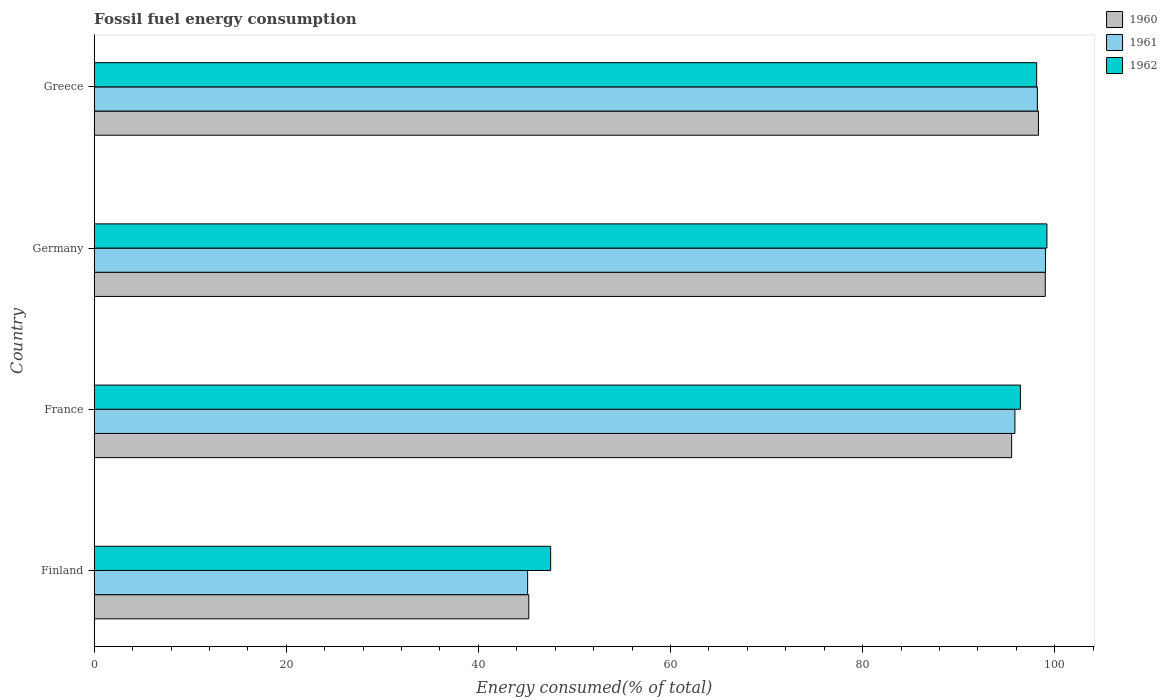How many different coloured bars are there?
Give a very brief answer. 3. How many bars are there on the 3rd tick from the top?
Offer a terse response. 3. What is the label of the 3rd group of bars from the top?
Offer a very short reply. France. What is the percentage of energy consumed in 1960 in Germany?
Your answer should be very brief. 99.02. Across all countries, what is the maximum percentage of energy consumed in 1962?
Keep it short and to the point. 99.19. Across all countries, what is the minimum percentage of energy consumed in 1962?
Ensure brevity in your answer.  47.52. In which country was the percentage of energy consumed in 1962 maximum?
Provide a short and direct response. Germany. In which country was the percentage of energy consumed in 1960 minimum?
Give a very brief answer. Finland. What is the total percentage of energy consumed in 1961 in the graph?
Keep it short and to the point. 338.23. What is the difference between the percentage of energy consumed in 1961 in Finland and that in France?
Provide a succinct answer. -50.73. What is the difference between the percentage of energy consumed in 1961 in Greece and the percentage of energy consumed in 1962 in Germany?
Your answer should be very brief. -0.99. What is the average percentage of energy consumed in 1962 per country?
Provide a succinct answer. 85.32. What is the difference between the percentage of energy consumed in 1961 and percentage of energy consumed in 1960 in Germany?
Provide a short and direct response. 0.02. What is the ratio of the percentage of energy consumed in 1961 in Germany to that in Greece?
Ensure brevity in your answer.  1.01. Is the percentage of energy consumed in 1961 in Finland less than that in Greece?
Make the answer very short. Yes. Is the difference between the percentage of energy consumed in 1961 in Germany and Greece greater than the difference between the percentage of energy consumed in 1960 in Germany and Greece?
Keep it short and to the point. Yes. What is the difference between the highest and the second highest percentage of energy consumed in 1961?
Give a very brief answer. 0.84. What is the difference between the highest and the lowest percentage of energy consumed in 1961?
Offer a very short reply. 53.91. In how many countries, is the percentage of energy consumed in 1962 greater than the average percentage of energy consumed in 1962 taken over all countries?
Your answer should be very brief. 3. Is the sum of the percentage of energy consumed in 1960 in Finland and Greece greater than the maximum percentage of energy consumed in 1962 across all countries?
Provide a succinct answer. Yes. Is it the case that in every country, the sum of the percentage of energy consumed in 1962 and percentage of energy consumed in 1960 is greater than the percentage of energy consumed in 1961?
Ensure brevity in your answer.  Yes. How many bars are there?
Make the answer very short. 12. Are all the bars in the graph horizontal?
Keep it short and to the point. Yes. What is the difference between two consecutive major ticks on the X-axis?
Offer a very short reply. 20. Does the graph contain any zero values?
Your answer should be compact. No. Does the graph contain grids?
Provide a short and direct response. No. How many legend labels are there?
Your answer should be compact. 3. How are the legend labels stacked?
Ensure brevity in your answer.  Vertical. What is the title of the graph?
Your answer should be compact. Fossil fuel energy consumption. Does "2010" appear as one of the legend labels in the graph?
Provide a succinct answer. No. What is the label or title of the X-axis?
Ensure brevity in your answer.  Energy consumed(% of total). What is the label or title of the Y-axis?
Offer a terse response. Country. What is the Energy consumed(% of total) in 1960 in Finland?
Make the answer very short. 45.25. What is the Energy consumed(% of total) of 1961 in Finland?
Keep it short and to the point. 45.13. What is the Energy consumed(% of total) of 1962 in Finland?
Keep it short and to the point. 47.52. What is the Energy consumed(% of total) in 1960 in France?
Offer a very short reply. 95.52. What is the Energy consumed(% of total) in 1961 in France?
Your answer should be very brief. 95.86. What is the Energy consumed(% of total) in 1962 in France?
Your answer should be compact. 96.43. What is the Energy consumed(% of total) in 1960 in Germany?
Your answer should be very brief. 99.02. What is the Energy consumed(% of total) of 1961 in Germany?
Offer a terse response. 99.04. What is the Energy consumed(% of total) in 1962 in Germany?
Offer a very short reply. 99.19. What is the Energy consumed(% of total) in 1960 in Greece?
Keep it short and to the point. 98.31. What is the Energy consumed(% of total) in 1961 in Greece?
Make the answer very short. 98.2. What is the Energy consumed(% of total) of 1962 in Greece?
Offer a very short reply. 98.12. Across all countries, what is the maximum Energy consumed(% of total) of 1960?
Provide a succinct answer. 99.02. Across all countries, what is the maximum Energy consumed(% of total) of 1961?
Provide a succinct answer. 99.04. Across all countries, what is the maximum Energy consumed(% of total) in 1962?
Provide a short and direct response. 99.19. Across all countries, what is the minimum Energy consumed(% of total) in 1960?
Your answer should be compact. 45.25. Across all countries, what is the minimum Energy consumed(% of total) in 1961?
Your answer should be very brief. 45.13. Across all countries, what is the minimum Energy consumed(% of total) in 1962?
Give a very brief answer. 47.52. What is the total Energy consumed(% of total) in 1960 in the graph?
Offer a very short reply. 338.1. What is the total Energy consumed(% of total) in 1961 in the graph?
Offer a terse response. 338.23. What is the total Energy consumed(% of total) in 1962 in the graph?
Provide a succinct answer. 341.27. What is the difference between the Energy consumed(% of total) in 1960 in Finland and that in France?
Give a very brief answer. -50.27. What is the difference between the Energy consumed(% of total) in 1961 in Finland and that in France?
Your answer should be very brief. -50.73. What is the difference between the Energy consumed(% of total) of 1962 in Finland and that in France?
Your response must be concise. -48.91. What is the difference between the Energy consumed(% of total) of 1960 in Finland and that in Germany?
Ensure brevity in your answer.  -53.77. What is the difference between the Energy consumed(% of total) of 1961 in Finland and that in Germany?
Provide a short and direct response. -53.91. What is the difference between the Energy consumed(% of total) of 1962 in Finland and that in Germany?
Your answer should be very brief. -51.67. What is the difference between the Energy consumed(% of total) in 1960 in Finland and that in Greece?
Your answer should be very brief. -53.07. What is the difference between the Energy consumed(% of total) of 1961 in Finland and that in Greece?
Your response must be concise. -53.07. What is the difference between the Energy consumed(% of total) in 1962 in Finland and that in Greece?
Provide a short and direct response. -50.6. What is the difference between the Energy consumed(% of total) of 1961 in France and that in Germany?
Ensure brevity in your answer.  -3.18. What is the difference between the Energy consumed(% of total) in 1962 in France and that in Germany?
Your answer should be very brief. -2.76. What is the difference between the Energy consumed(% of total) in 1960 in France and that in Greece?
Give a very brief answer. -2.79. What is the difference between the Energy consumed(% of total) in 1961 in France and that in Greece?
Keep it short and to the point. -2.34. What is the difference between the Energy consumed(% of total) in 1962 in France and that in Greece?
Your response must be concise. -1.69. What is the difference between the Energy consumed(% of total) of 1960 in Germany and that in Greece?
Make the answer very short. 0.71. What is the difference between the Energy consumed(% of total) of 1961 in Germany and that in Greece?
Ensure brevity in your answer.  0.84. What is the difference between the Energy consumed(% of total) in 1962 in Germany and that in Greece?
Provide a succinct answer. 1.07. What is the difference between the Energy consumed(% of total) in 1960 in Finland and the Energy consumed(% of total) in 1961 in France?
Your response must be concise. -50.62. What is the difference between the Energy consumed(% of total) in 1960 in Finland and the Energy consumed(% of total) in 1962 in France?
Ensure brevity in your answer.  -51.19. What is the difference between the Energy consumed(% of total) of 1961 in Finland and the Energy consumed(% of total) of 1962 in France?
Provide a short and direct response. -51.3. What is the difference between the Energy consumed(% of total) of 1960 in Finland and the Energy consumed(% of total) of 1961 in Germany?
Your answer should be compact. -53.8. What is the difference between the Energy consumed(% of total) of 1960 in Finland and the Energy consumed(% of total) of 1962 in Germany?
Provide a short and direct response. -53.95. What is the difference between the Energy consumed(% of total) of 1961 in Finland and the Energy consumed(% of total) of 1962 in Germany?
Your answer should be very brief. -54.06. What is the difference between the Energy consumed(% of total) in 1960 in Finland and the Energy consumed(% of total) in 1961 in Greece?
Give a very brief answer. -52.95. What is the difference between the Energy consumed(% of total) in 1960 in Finland and the Energy consumed(% of total) in 1962 in Greece?
Your answer should be very brief. -52.88. What is the difference between the Energy consumed(% of total) in 1961 in Finland and the Energy consumed(% of total) in 1962 in Greece?
Offer a very short reply. -53. What is the difference between the Energy consumed(% of total) of 1960 in France and the Energy consumed(% of total) of 1961 in Germany?
Provide a short and direct response. -3.52. What is the difference between the Energy consumed(% of total) of 1960 in France and the Energy consumed(% of total) of 1962 in Germany?
Keep it short and to the point. -3.67. What is the difference between the Energy consumed(% of total) of 1961 in France and the Energy consumed(% of total) of 1962 in Germany?
Offer a terse response. -3.33. What is the difference between the Energy consumed(% of total) in 1960 in France and the Energy consumed(% of total) in 1961 in Greece?
Make the answer very short. -2.68. What is the difference between the Energy consumed(% of total) of 1960 in France and the Energy consumed(% of total) of 1962 in Greece?
Provide a short and direct response. -2.6. What is the difference between the Energy consumed(% of total) in 1961 in France and the Energy consumed(% of total) in 1962 in Greece?
Keep it short and to the point. -2.26. What is the difference between the Energy consumed(% of total) of 1960 in Germany and the Energy consumed(% of total) of 1961 in Greece?
Give a very brief answer. 0.82. What is the difference between the Energy consumed(% of total) of 1960 in Germany and the Energy consumed(% of total) of 1962 in Greece?
Give a very brief answer. 0.9. What is the difference between the Energy consumed(% of total) in 1961 in Germany and the Energy consumed(% of total) in 1962 in Greece?
Make the answer very short. 0.92. What is the average Energy consumed(% of total) in 1960 per country?
Your response must be concise. 84.52. What is the average Energy consumed(% of total) in 1961 per country?
Offer a very short reply. 84.56. What is the average Energy consumed(% of total) in 1962 per country?
Provide a succinct answer. 85.32. What is the difference between the Energy consumed(% of total) of 1960 and Energy consumed(% of total) of 1961 in Finland?
Ensure brevity in your answer.  0.12. What is the difference between the Energy consumed(% of total) in 1960 and Energy consumed(% of total) in 1962 in Finland?
Give a very brief answer. -2.28. What is the difference between the Energy consumed(% of total) of 1961 and Energy consumed(% of total) of 1962 in Finland?
Keep it short and to the point. -2.4. What is the difference between the Energy consumed(% of total) of 1960 and Energy consumed(% of total) of 1961 in France?
Provide a short and direct response. -0.34. What is the difference between the Energy consumed(% of total) in 1960 and Energy consumed(% of total) in 1962 in France?
Ensure brevity in your answer.  -0.91. What is the difference between the Energy consumed(% of total) in 1961 and Energy consumed(% of total) in 1962 in France?
Give a very brief answer. -0.57. What is the difference between the Energy consumed(% of total) in 1960 and Energy consumed(% of total) in 1961 in Germany?
Keep it short and to the point. -0.02. What is the difference between the Energy consumed(% of total) in 1960 and Energy consumed(% of total) in 1962 in Germany?
Your response must be concise. -0.17. What is the difference between the Energy consumed(% of total) in 1961 and Energy consumed(% of total) in 1962 in Germany?
Make the answer very short. -0.15. What is the difference between the Energy consumed(% of total) of 1960 and Energy consumed(% of total) of 1961 in Greece?
Provide a short and direct response. 0.11. What is the difference between the Energy consumed(% of total) of 1960 and Energy consumed(% of total) of 1962 in Greece?
Ensure brevity in your answer.  0.19. What is the difference between the Energy consumed(% of total) of 1961 and Energy consumed(% of total) of 1962 in Greece?
Ensure brevity in your answer.  0.07. What is the ratio of the Energy consumed(% of total) in 1960 in Finland to that in France?
Provide a short and direct response. 0.47. What is the ratio of the Energy consumed(% of total) of 1961 in Finland to that in France?
Offer a very short reply. 0.47. What is the ratio of the Energy consumed(% of total) in 1962 in Finland to that in France?
Your response must be concise. 0.49. What is the ratio of the Energy consumed(% of total) in 1960 in Finland to that in Germany?
Provide a short and direct response. 0.46. What is the ratio of the Energy consumed(% of total) in 1961 in Finland to that in Germany?
Your answer should be compact. 0.46. What is the ratio of the Energy consumed(% of total) in 1962 in Finland to that in Germany?
Your answer should be very brief. 0.48. What is the ratio of the Energy consumed(% of total) of 1960 in Finland to that in Greece?
Make the answer very short. 0.46. What is the ratio of the Energy consumed(% of total) in 1961 in Finland to that in Greece?
Keep it short and to the point. 0.46. What is the ratio of the Energy consumed(% of total) in 1962 in Finland to that in Greece?
Ensure brevity in your answer.  0.48. What is the ratio of the Energy consumed(% of total) in 1960 in France to that in Germany?
Your response must be concise. 0.96. What is the ratio of the Energy consumed(% of total) of 1961 in France to that in Germany?
Your response must be concise. 0.97. What is the ratio of the Energy consumed(% of total) of 1962 in France to that in Germany?
Your answer should be very brief. 0.97. What is the ratio of the Energy consumed(% of total) in 1960 in France to that in Greece?
Offer a terse response. 0.97. What is the ratio of the Energy consumed(% of total) in 1961 in France to that in Greece?
Keep it short and to the point. 0.98. What is the ratio of the Energy consumed(% of total) in 1962 in France to that in Greece?
Make the answer very short. 0.98. What is the ratio of the Energy consumed(% of total) of 1961 in Germany to that in Greece?
Your response must be concise. 1.01. What is the ratio of the Energy consumed(% of total) of 1962 in Germany to that in Greece?
Ensure brevity in your answer.  1.01. What is the difference between the highest and the second highest Energy consumed(% of total) in 1960?
Provide a succinct answer. 0.71. What is the difference between the highest and the second highest Energy consumed(% of total) in 1961?
Ensure brevity in your answer.  0.84. What is the difference between the highest and the second highest Energy consumed(% of total) in 1962?
Your response must be concise. 1.07. What is the difference between the highest and the lowest Energy consumed(% of total) of 1960?
Your answer should be very brief. 53.77. What is the difference between the highest and the lowest Energy consumed(% of total) of 1961?
Make the answer very short. 53.91. What is the difference between the highest and the lowest Energy consumed(% of total) in 1962?
Make the answer very short. 51.67. 